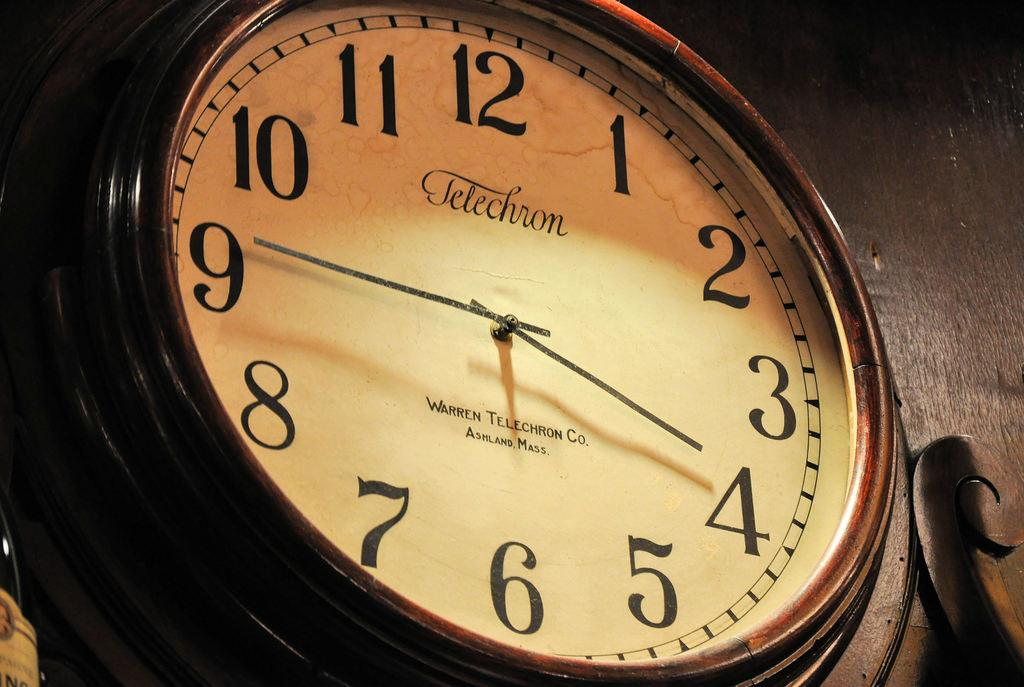<image>
Render a clear and concise summary of the photo. A clock made by Telechron shows that the time is 3:45. 